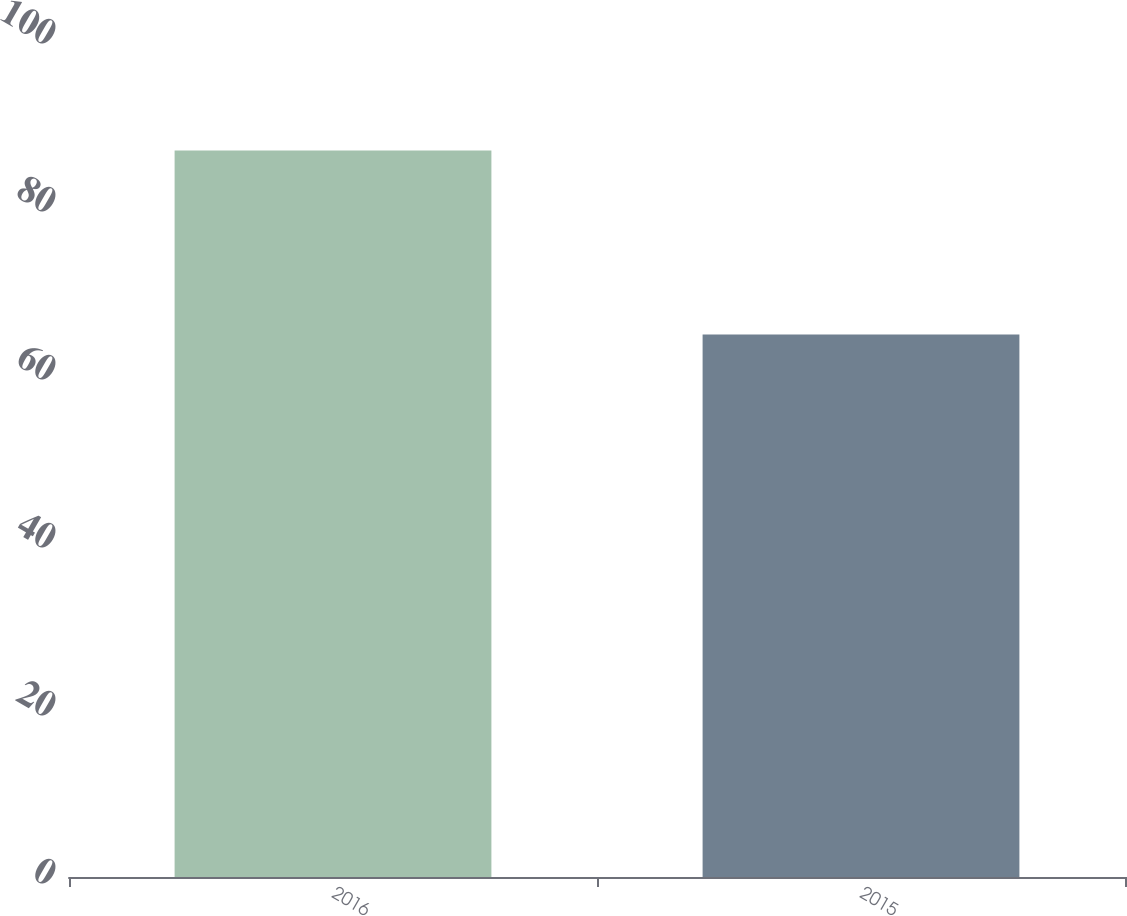Convert chart to OTSL. <chart><loc_0><loc_0><loc_500><loc_500><bar_chart><fcel>2016<fcel>2015<nl><fcel>86.5<fcel>64.59<nl></chart> 